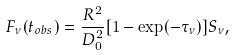Convert formula to latex. <formula><loc_0><loc_0><loc_500><loc_500>F _ { \nu } ( t _ { o b s } ) = \frac { R ^ { 2 } } { D _ { 0 } ^ { 2 } } [ 1 - \exp ( - \tau _ { \nu } ) ] S _ { \nu } ,</formula> 